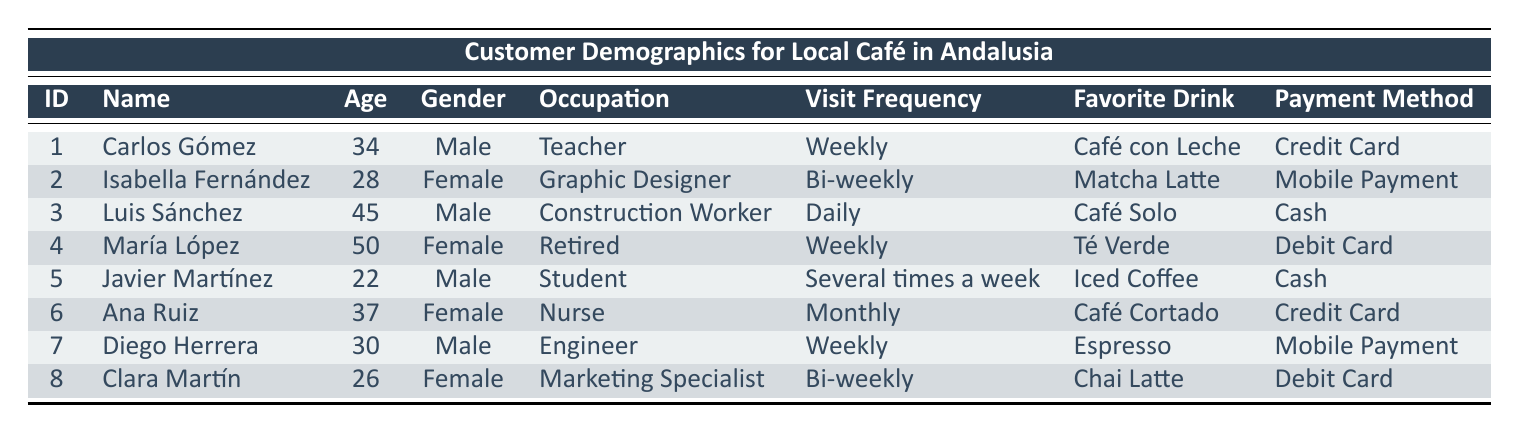What is the favorite drink of Diego Herrera? Referring to the table, we see that Diego Herrera's entry is in row 7, and his favorite drink is listed as Espresso.
Answer: Espresso How many customers have a visit frequency of "Weekly"? Looking through the table, Carlos Gómez, María López, and Diego Herrera all have a visit frequency of "Weekly". This results in a total of 3 customers.
Answer: 3 Is Isabella Fernández a Graphic Designer? Checking the table, Isabella Fernández's occupation is listed as Graphic Designer, which confirms that this statement is true.
Answer: Yes What is the average age of customers who prefer Cash as their payment method? The customers who prefer Cash are Luis Sánchez (45), Javier Martínez (22), and Diego Herrera (30). The average age is calculated as (45 + 22 + 30) / 3 = 97 / 3 = 32.33, which rounds to about 32 years.
Answer: 32 How many male customers prefer Mobile Payment? From the table, Diego Herrera prefers Mobile Payment, and thus the total number of male customers who prefer this payment method is just 1.
Answer: 1 What is the occupation of the youngest customer? The youngest customer is Javier Martínez at age 22, whose occupation is a Student as seen in row 5.
Answer: Student Are there more female customers than male customers? Looking at the table, there are 4 females (Isabella Fernández, María López, Ana Ruiz, and Clara Martín) and 4 males (Carlos Gómez, Luis Sánchez, Javier Martínez, and Diego Herrera). Since the numbers are equal, this statement is false.
Answer: No What is the favorite drink of the customer who visits the café the most frequently? The customer who visits the café daily is Luis Sánchez, and his favorite drink is listed as Café Solo.
Answer: Café Solo 